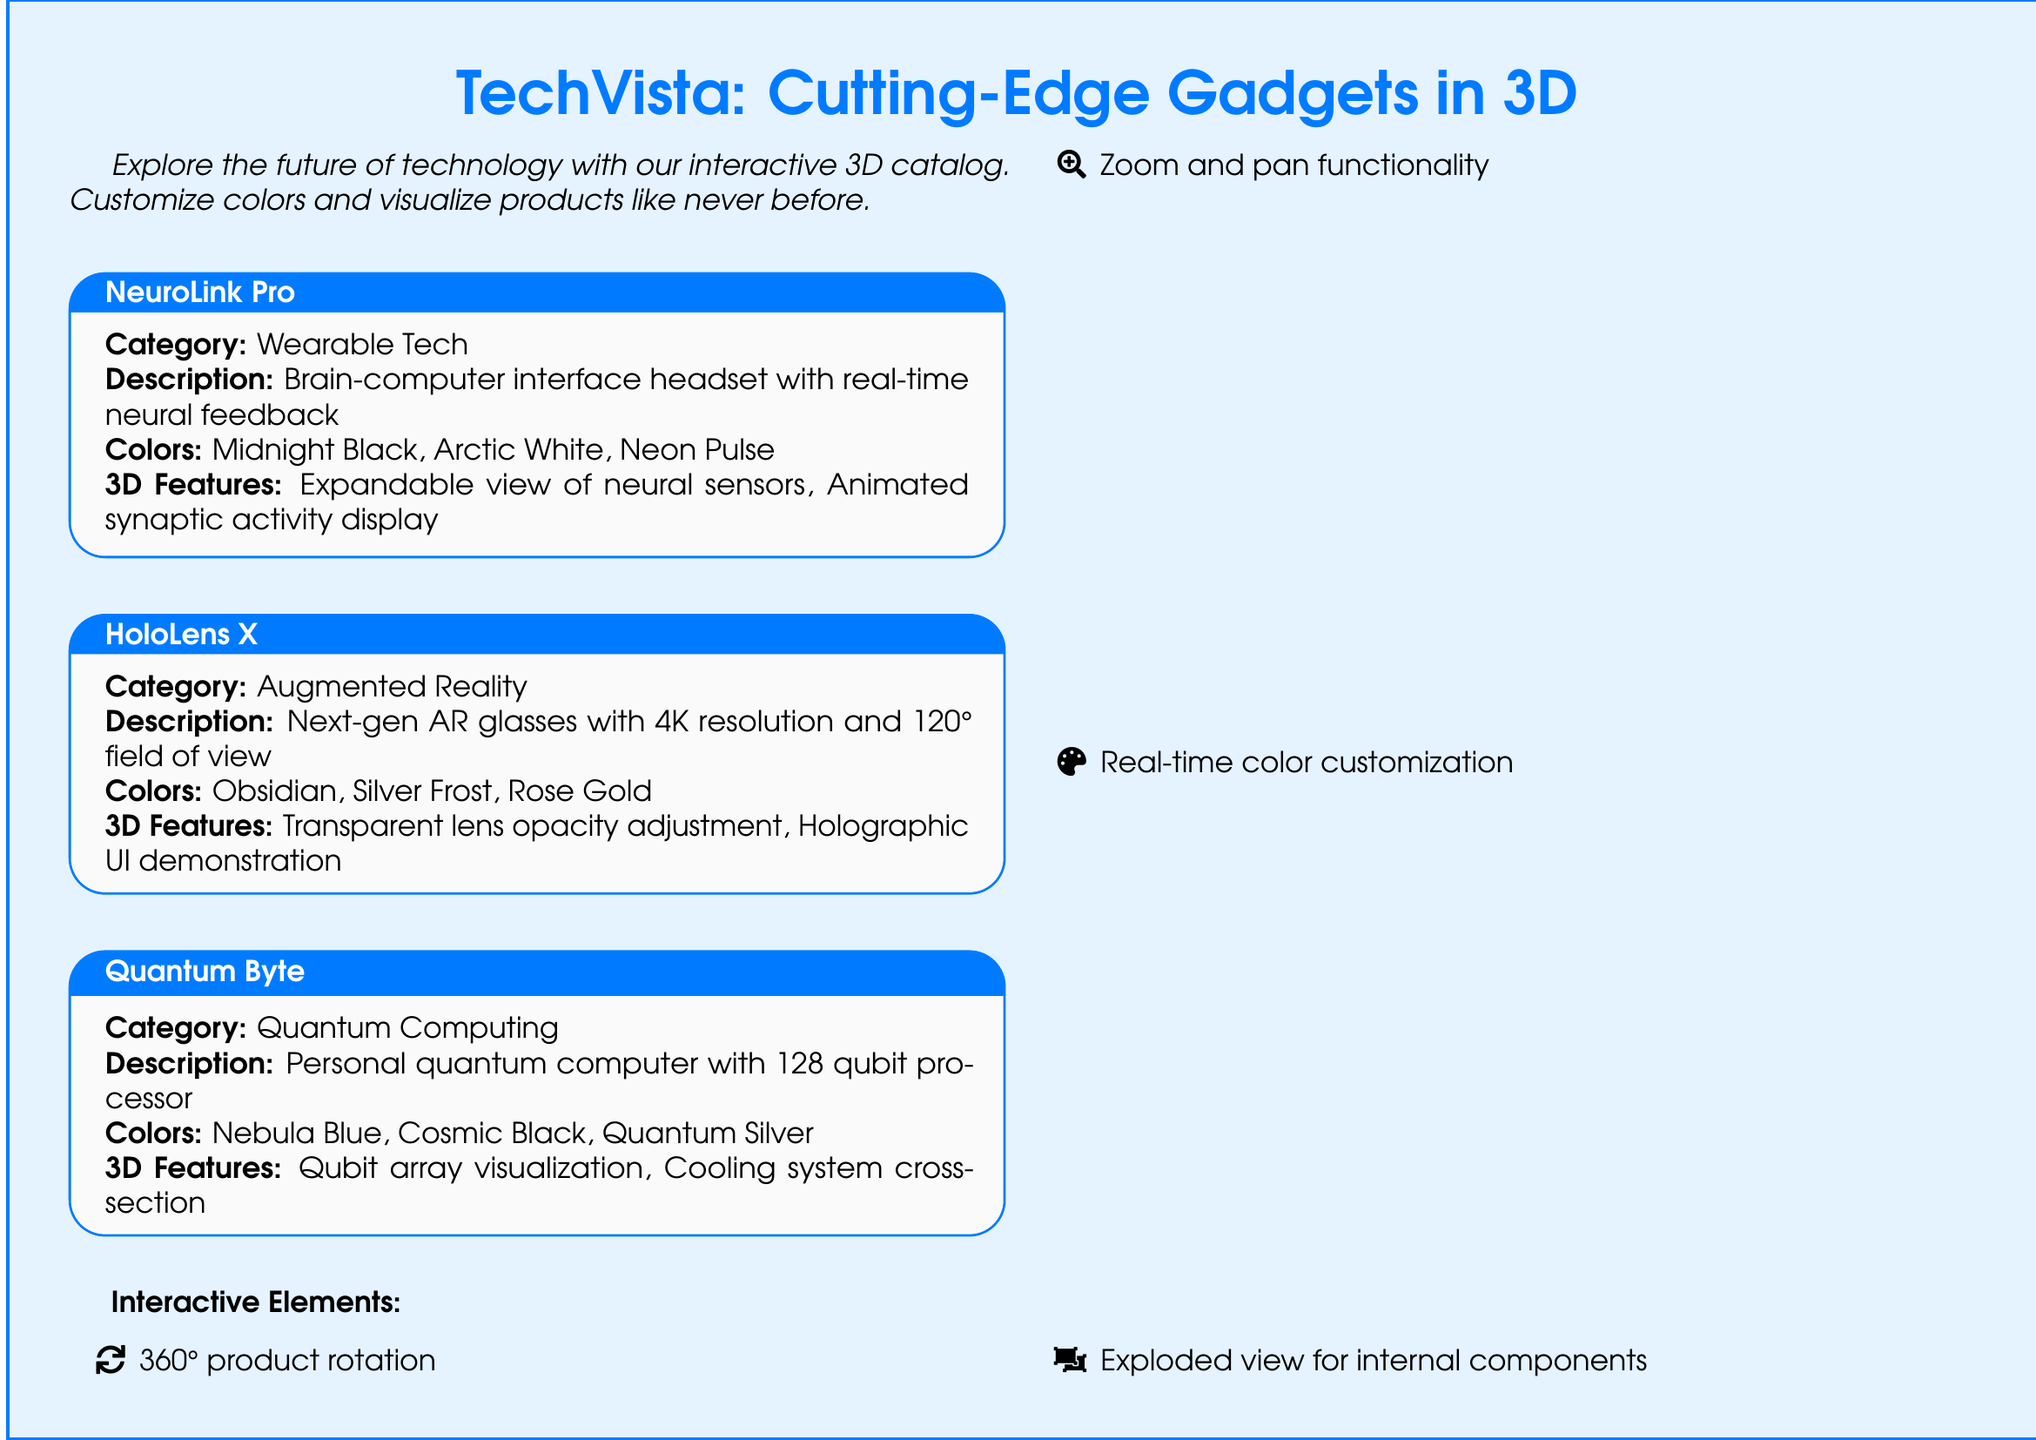What is the name of the first product listed? The first product listed in the catalog is titled "NeuroLink Pro."
Answer: NeuroLink Pro What color options are available for the HoloLens X? The color options available for HoloLens X are specified in the product box as Obsidian, Silver Frost, and Rose Gold.
Answer: Obsidian, Silver Frost, Rose Gold How many types of tech gadgets are featured in the catalog? The catalog features a total of three different tech gadgets: NeuroLink Pro, HoloLens X, and Quantum Byte.
Answer: Three What unique feature does the Quantum Byte offer? The unique feature of Quantum Byte includes a cooling system cross-section visualization as detailed in its product box.
Answer: Cooling system cross-section Which interactive element allows 360° product rotation? The document specifies that the interactive element enabling 360° product rotation is represented by the sync icon.
Answer: Sync icon What is the purpose of the performance comparison chart? The performance comparison chart is designed to compare key metrics such as Processing Power, Energy Efficiency, and User Interface Intuitiveness.
Answer: Compare key metrics What is the background color of the page? The background color of the page is a light blue tint as defined in the TikZ settings with techblue!10.
Answer: Light blue tint What is the main theme of the interactive catalog? The theme of the interactive catalog revolves around exploring the future of technology through 3D visualizations.
Answer: Future of technology 